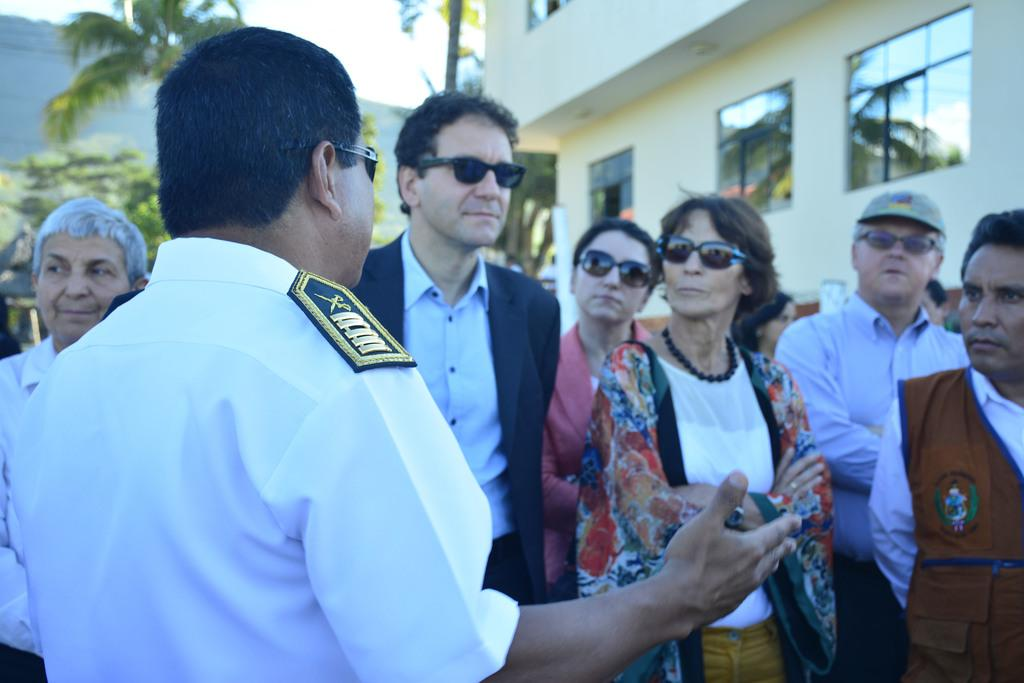What is happening in the image? There are people standing in the image. Can you describe the appearance of some of the people? Some people in the image are wearing sunglasses. What can be seen in the background of the image? There is a building, trees, and a hill in the image. How would you describe the weather based on the image? The sky is cloudy in the image. What is the value of the fork in the image? There is no fork present in the image, so it is not possible to determine its value. 